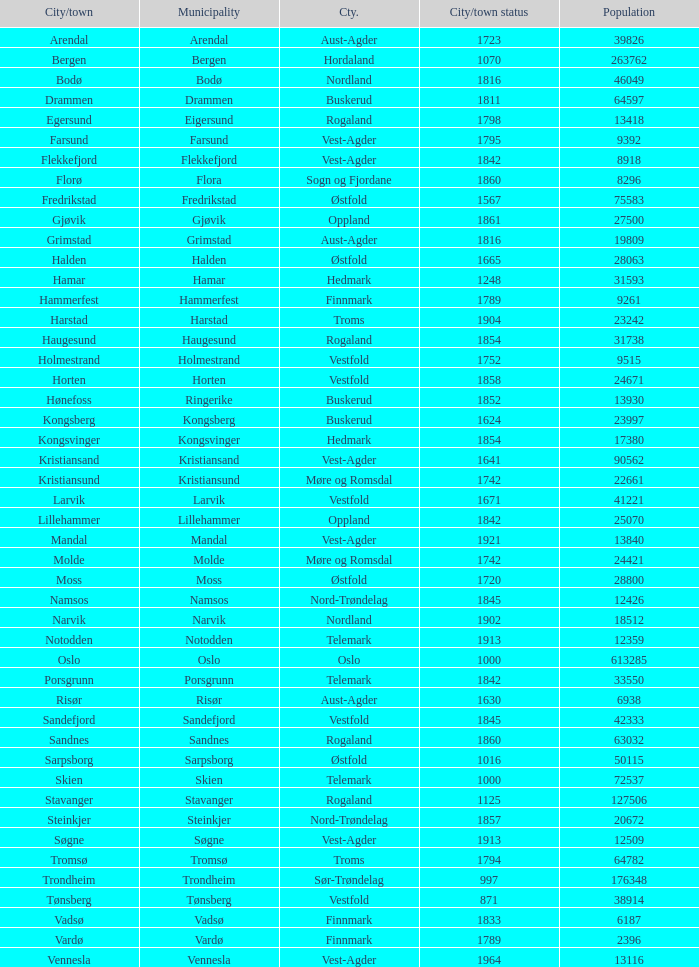In the municipality of horten, what are the various towns or cities situated there? Horten. 